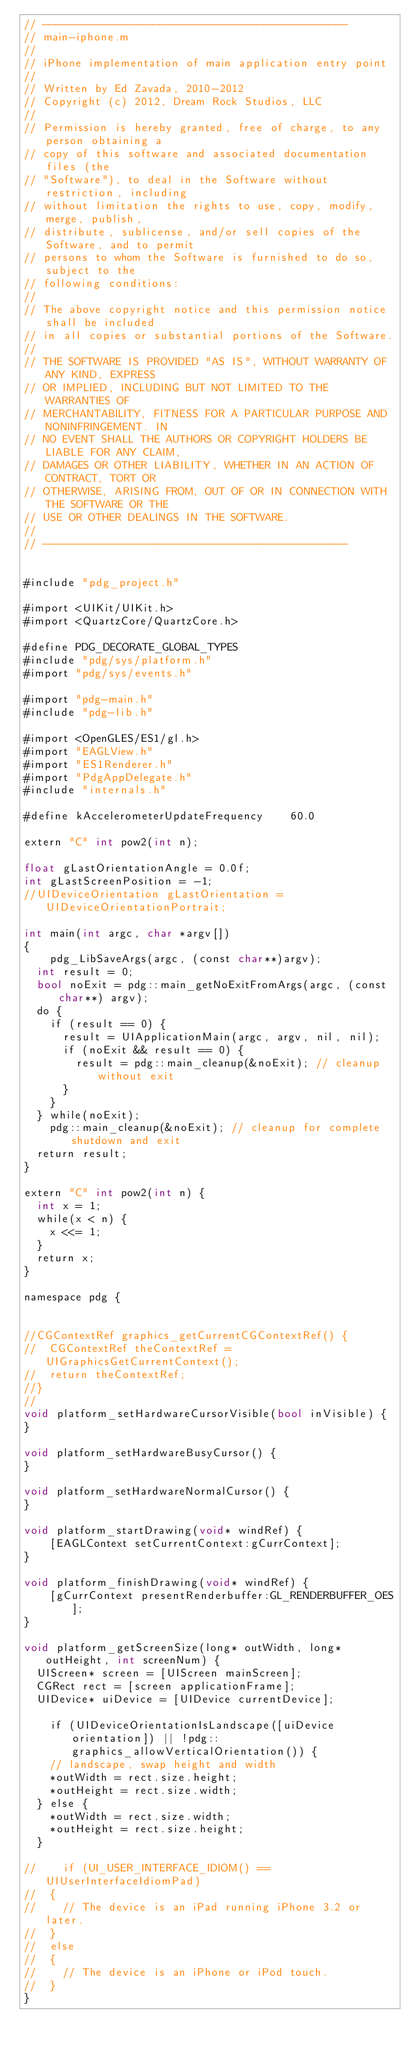<code> <loc_0><loc_0><loc_500><loc_500><_ObjectiveC_>// -----------------------------------------------
// main-iphone.m
// 
// iPhone implementation of main application entry point
//
// Written by Ed Zavada, 2010-2012
// Copyright (c) 2012, Dream Rock Studios, LLC
//
// Permission is hereby granted, free of charge, to any person obtaining a
// copy of this software and associated documentation files (the
// "Software"), to deal in the Software without restriction, including
// without limitation the rights to use, copy, modify, merge, publish,
// distribute, sublicense, and/or sell copies of the Software, and to permit
// persons to whom the Software is furnished to do so, subject to the
// following conditions:
//
// The above copyright notice and this permission notice shall be included
// in all copies or substantial portions of the Software.
//
// THE SOFTWARE IS PROVIDED "AS IS", WITHOUT WARRANTY OF ANY KIND, EXPRESS
// OR IMPLIED, INCLUDING BUT NOT LIMITED TO THE WARRANTIES OF
// MERCHANTABILITY, FITNESS FOR A PARTICULAR PURPOSE AND NONINFRINGEMENT. IN
// NO EVENT SHALL THE AUTHORS OR COPYRIGHT HOLDERS BE LIABLE FOR ANY CLAIM,
// DAMAGES OR OTHER LIABILITY, WHETHER IN AN ACTION OF CONTRACT, TORT OR
// OTHERWISE, ARISING FROM, OUT OF OR IN CONNECTION WITH THE SOFTWARE OR THE
// USE OR OTHER DEALINGS IN THE SOFTWARE.
//
// -----------------------------------------------


#include "pdg_project.h"

#import <UIKit/UIKit.h>
#import <QuartzCore/QuartzCore.h>

#define PDG_DECORATE_GLOBAL_TYPES
#include "pdg/sys/platform.h"
#import "pdg/sys/events.h"

#import "pdg-main.h"
#include "pdg-lib.h"

#import <OpenGLES/ES1/gl.h>
#import "EAGLView.h"
#import "ES1Renderer.h"
#import "PdgAppDelegate.h"
#include "internals.h"

#define kAccelerometerUpdateFrequency    60.0

extern "C" int pow2(int n);

float gLastOrientationAngle = 0.0f;
int gLastScreenPosition = -1;
//UIDeviceOrientation gLastOrientation = UIDeviceOrientationPortrait;

int main(int argc, char *argv[])
{
    pdg_LibSaveArgs(argc, (const char**)argv);
	int result = 0;
	bool noExit = pdg::main_getNoExitFromArgs(argc, (const char**) argv);
	do {
		if (result == 0) {
			result = UIApplicationMain(argc, argv, nil, nil);
			if (noExit && result == 0) {
				result = pdg::main_cleanup(&noExit); // cleanup without exit
			}
		}
	} while(noExit);
    pdg::main_cleanup(&noExit); // cleanup for complete shutdown and exit
	return result;
}

extern "C" int pow2(int n) {
	int x = 1;
	while(x < n) {
		x <<= 1;
	}
	return x;
}

namespace pdg {
    

//CGContextRef graphics_getCurrentCGContextRef() {
//	CGContextRef theContextRef = UIGraphicsGetCurrentContext();
//	return theContextRef;
//}
//
void platform_setHardwareCursorVisible(bool inVisible) {
}

void platform_setHardwareBusyCursor() {
}

void platform_setHardwareNormalCursor() {
}

void platform_startDrawing(void* windRef) {
    [EAGLContext setCurrentContext:gCurrContext];
}

void platform_finishDrawing(void* windRef) {
    [gCurrContext presentRenderbuffer:GL_RENDERBUFFER_OES];
}

void platform_getScreenSize(long* outWidth, long* outHeight, int screenNum) {
	UIScreen* screen = [UIScreen mainScreen];
	CGRect rect = [screen applicationFrame];
	UIDevice* uiDevice = [UIDevice currentDevice];

    if (UIDeviceOrientationIsLandscape([uiDevice orientation]) || !pdg::graphics_allowVerticalOrientation()) {
		// landscape, swap height and width
		*outWidth = rect.size.height;
		*outHeight = rect.size.width;
	} else {
		*outWidth = rect.size.width;
		*outHeight = rect.size.height;		
	}

//    if (UI_USER_INTERFACE_IDIOM() == UIUserInterfaceIdiomPad)
//	{
//		// The device is an iPad running iPhone 3.2 or later.
//	}
//	else
//	{
//		// The device is an iPhone or iPod touch.
//	}
}
</code> 